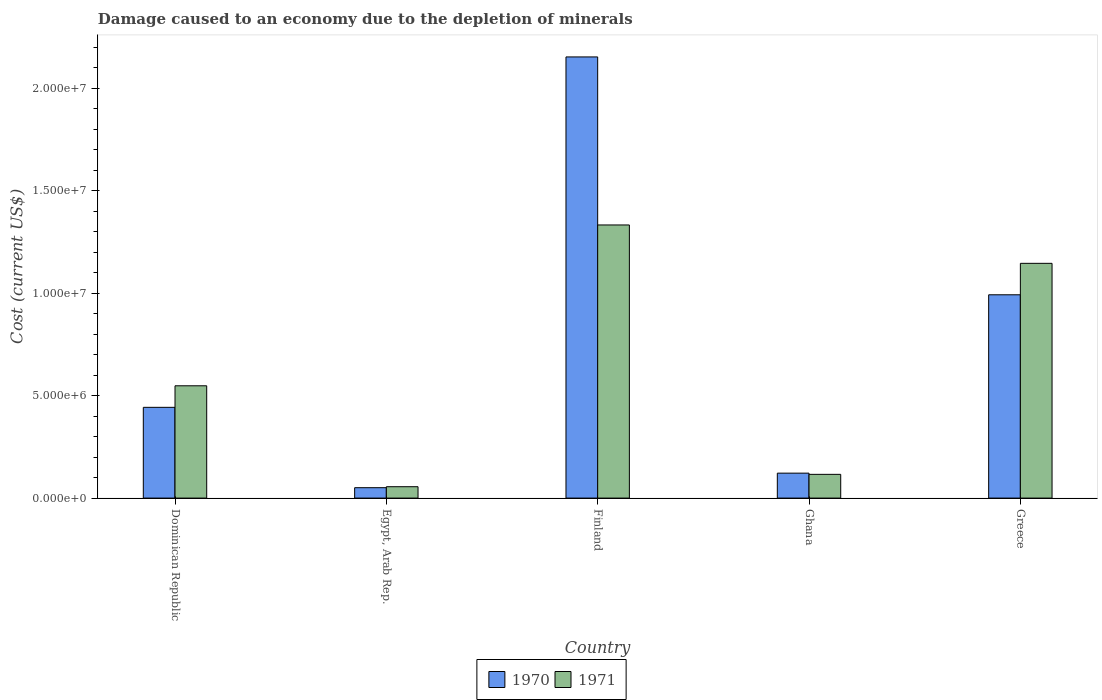How many bars are there on the 5th tick from the left?
Offer a terse response. 2. How many bars are there on the 4th tick from the right?
Provide a succinct answer. 2. What is the cost of damage caused due to the depletion of minerals in 1970 in Finland?
Make the answer very short. 2.15e+07. Across all countries, what is the maximum cost of damage caused due to the depletion of minerals in 1970?
Offer a very short reply. 2.15e+07. Across all countries, what is the minimum cost of damage caused due to the depletion of minerals in 1971?
Your response must be concise. 5.55e+05. In which country was the cost of damage caused due to the depletion of minerals in 1970 maximum?
Provide a short and direct response. Finland. In which country was the cost of damage caused due to the depletion of minerals in 1971 minimum?
Make the answer very short. Egypt, Arab Rep. What is the total cost of damage caused due to the depletion of minerals in 1971 in the graph?
Make the answer very short. 3.20e+07. What is the difference between the cost of damage caused due to the depletion of minerals in 1971 in Dominican Republic and that in Ghana?
Keep it short and to the point. 4.32e+06. What is the difference between the cost of damage caused due to the depletion of minerals in 1971 in Dominican Republic and the cost of damage caused due to the depletion of minerals in 1970 in Greece?
Your answer should be very brief. -4.44e+06. What is the average cost of damage caused due to the depletion of minerals in 1970 per country?
Make the answer very short. 7.52e+06. What is the difference between the cost of damage caused due to the depletion of minerals of/in 1971 and cost of damage caused due to the depletion of minerals of/in 1970 in Ghana?
Offer a terse response. -5.86e+04. What is the ratio of the cost of damage caused due to the depletion of minerals in 1971 in Egypt, Arab Rep. to that in Ghana?
Offer a very short reply. 0.48. Is the difference between the cost of damage caused due to the depletion of minerals in 1971 in Finland and Ghana greater than the difference between the cost of damage caused due to the depletion of minerals in 1970 in Finland and Ghana?
Offer a very short reply. No. What is the difference between the highest and the second highest cost of damage caused due to the depletion of minerals in 1970?
Keep it short and to the point. -1.16e+07. What is the difference between the highest and the lowest cost of damage caused due to the depletion of minerals in 1970?
Keep it short and to the point. 2.10e+07. Is the sum of the cost of damage caused due to the depletion of minerals in 1970 in Dominican Republic and Finland greater than the maximum cost of damage caused due to the depletion of minerals in 1971 across all countries?
Provide a short and direct response. Yes. What does the 2nd bar from the right in Finland represents?
Ensure brevity in your answer.  1970. Are all the bars in the graph horizontal?
Give a very brief answer. No. How many legend labels are there?
Your answer should be compact. 2. What is the title of the graph?
Your answer should be very brief. Damage caused to an economy due to the depletion of minerals. What is the label or title of the X-axis?
Offer a terse response. Country. What is the label or title of the Y-axis?
Provide a succinct answer. Cost (current US$). What is the Cost (current US$) of 1970 in Dominican Republic?
Make the answer very short. 4.43e+06. What is the Cost (current US$) of 1971 in Dominican Republic?
Give a very brief answer. 5.48e+06. What is the Cost (current US$) of 1970 in Egypt, Arab Rep.?
Your answer should be compact. 5.07e+05. What is the Cost (current US$) of 1971 in Egypt, Arab Rep.?
Keep it short and to the point. 5.55e+05. What is the Cost (current US$) of 1970 in Finland?
Your response must be concise. 2.15e+07. What is the Cost (current US$) in 1971 in Finland?
Offer a very short reply. 1.33e+07. What is the Cost (current US$) of 1970 in Ghana?
Your answer should be very brief. 1.22e+06. What is the Cost (current US$) of 1971 in Ghana?
Ensure brevity in your answer.  1.16e+06. What is the Cost (current US$) of 1970 in Greece?
Ensure brevity in your answer.  9.92e+06. What is the Cost (current US$) of 1971 in Greece?
Your answer should be very brief. 1.15e+07. Across all countries, what is the maximum Cost (current US$) of 1970?
Give a very brief answer. 2.15e+07. Across all countries, what is the maximum Cost (current US$) in 1971?
Your answer should be very brief. 1.33e+07. Across all countries, what is the minimum Cost (current US$) of 1970?
Make the answer very short. 5.07e+05. Across all countries, what is the minimum Cost (current US$) in 1971?
Offer a very short reply. 5.55e+05. What is the total Cost (current US$) in 1970 in the graph?
Provide a short and direct response. 3.76e+07. What is the total Cost (current US$) in 1971 in the graph?
Ensure brevity in your answer.  3.20e+07. What is the difference between the Cost (current US$) of 1970 in Dominican Republic and that in Egypt, Arab Rep.?
Your answer should be compact. 3.92e+06. What is the difference between the Cost (current US$) of 1971 in Dominican Republic and that in Egypt, Arab Rep.?
Provide a short and direct response. 4.92e+06. What is the difference between the Cost (current US$) in 1970 in Dominican Republic and that in Finland?
Your response must be concise. -1.71e+07. What is the difference between the Cost (current US$) of 1971 in Dominican Republic and that in Finland?
Provide a short and direct response. -7.85e+06. What is the difference between the Cost (current US$) of 1970 in Dominican Republic and that in Ghana?
Ensure brevity in your answer.  3.21e+06. What is the difference between the Cost (current US$) in 1971 in Dominican Republic and that in Ghana?
Offer a very short reply. 4.32e+06. What is the difference between the Cost (current US$) of 1970 in Dominican Republic and that in Greece?
Provide a succinct answer. -5.49e+06. What is the difference between the Cost (current US$) in 1971 in Dominican Republic and that in Greece?
Provide a succinct answer. -5.97e+06. What is the difference between the Cost (current US$) of 1970 in Egypt, Arab Rep. and that in Finland?
Your answer should be compact. -2.10e+07. What is the difference between the Cost (current US$) in 1971 in Egypt, Arab Rep. and that in Finland?
Your answer should be very brief. -1.28e+07. What is the difference between the Cost (current US$) in 1970 in Egypt, Arab Rep. and that in Ghana?
Your answer should be very brief. -7.10e+05. What is the difference between the Cost (current US$) of 1971 in Egypt, Arab Rep. and that in Ghana?
Provide a short and direct response. -6.03e+05. What is the difference between the Cost (current US$) in 1970 in Egypt, Arab Rep. and that in Greece?
Offer a very short reply. -9.41e+06. What is the difference between the Cost (current US$) of 1971 in Egypt, Arab Rep. and that in Greece?
Offer a terse response. -1.09e+07. What is the difference between the Cost (current US$) of 1970 in Finland and that in Ghana?
Provide a succinct answer. 2.03e+07. What is the difference between the Cost (current US$) in 1971 in Finland and that in Ghana?
Make the answer very short. 1.22e+07. What is the difference between the Cost (current US$) of 1970 in Finland and that in Greece?
Make the answer very short. 1.16e+07. What is the difference between the Cost (current US$) in 1971 in Finland and that in Greece?
Provide a succinct answer. 1.87e+06. What is the difference between the Cost (current US$) of 1970 in Ghana and that in Greece?
Offer a terse response. -8.70e+06. What is the difference between the Cost (current US$) in 1971 in Ghana and that in Greece?
Make the answer very short. -1.03e+07. What is the difference between the Cost (current US$) in 1970 in Dominican Republic and the Cost (current US$) in 1971 in Egypt, Arab Rep.?
Ensure brevity in your answer.  3.87e+06. What is the difference between the Cost (current US$) of 1970 in Dominican Republic and the Cost (current US$) of 1971 in Finland?
Offer a very short reply. -8.90e+06. What is the difference between the Cost (current US$) in 1970 in Dominican Republic and the Cost (current US$) in 1971 in Ghana?
Offer a terse response. 3.27e+06. What is the difference between the Cost (current US$) in 1970 in Dominican Republic and the Cost (current US$) in 1971 in Greece?
Ensure brevity in your answer.  -7.02e+06. What is the difference between the Cost (current US$) of 1970 in Egypt, Arab Rep. and the Cost (current US$) of 1971 in Finland?
Offer a terse response. -1.28e+07. What is the difference between the Cost (current US$) of 1970 in Egypt, Arab Rep. and the Cost (current US$) of 1971 in Ghana?
Offer a terse response. -6.51e+05. What is the difference between the Cost (current US$) in 1970 in Egypt, Arab Rep. and the Cost (current US$) in 1971 in Greece?
Make the answer very short. -1.09e+07. What is the difference between the Cost (current US$) in 1970 in Finland and the Cost (current US$) in 1971 in Ghana?
Provide a succinct answer. 2.04e+07. What is the difference between the Cost (current US$) in 1970 in Finland and the Cost (current US$) in 1971 in Greece?
Your answer should be compact. 1.01e+07. What is the difference between the Cost (current US$) of 1970 in Ghana and the Cost (current US$) of 1971 in Greece?
Offer a terse response. -1.02e+07. What is the average Cost (current US$) of 1970 per country?
Provide a short and direct response. 7.52e+06. What is the average Cost (current US$) of 1971 per country?
Provide a succinct answer. 6.39e+06. What is the difference between the Cost (current US$) of 1970 and Cost (current US$) of 1971 in Dominican Republic?
Make the answer very short. -1.05e+06. What is the difference between the Cost (current US$) of 1970 and Cost (current US$) of 1971 in Egypt, Arab Rep.?
Provide a succinct answer. -4.79e+04. What is the difference between the Cost (current US$) of 1970 and Cost (current US$) of 1971 in Finland?
Your response must be concise. 8.20e+06. What is the difference between the Cost (current US$) of 1970 and Cost (current US$) of 1971 in Ghana?
Keep it short and to the point. 5.86e+04. What is the difference between the Cost (current US$) of 1970 and Cost (current US$) of 1971 in Greece?
Provide a short and direct response. -1.53e+06. What is the ratio of the Cost (current US$) in 1970 in Dominican Republic to that in Egypt, Arab Rep.?
Make the answer very short. 8.73. What is the ratio of the Cost (current US$) in 1971 in Dominican Republic to that in Egypt, Arab Rep.?
Provide a short and direct response. 9.87. What is the ratio of the Cost (current US$) in 1970 in Dominican Republic to that in Finland?
Your response must be concise. 0.21. What is the ratio of the Cost (current US$) in 1971 in Dominican Republic to that in Finland?
Provide a short and direct response. 0.41. What is the ratio of the Cost (current US$) of 1970 in Dominican Republic to that in Ghana?
Your answer should be compact. 3.64. What is the ratio of the Cost (current US$) of 1971 in Dominican Republic to that in Ghana?
Your answer should be very brief. 4.73. What is the ratio of the Cost (current US$) in 1970 in Dominican Republic to that in Greece?
Give a very brief answer. 0.45. What is the ratio of the Cost (current US$) of 1971 in Dominican Republic to that in Greece?
Provide a succinct answer. 0.48. What is the ratio of the Cost (current US$) of 1970 in Egypt, Arab Rep. to that in Finland?
Your answer should be very brief. 0.02. What is the ratio of the Cost (current US$) in 1971 in Egypt, Arab Rep. to that in Finland?
Ensure brevity in your answer.  0.04. What is the ratio of the Cost (current US$) of 1970 in Egypt, Arab Rep. to that in Ghana?
Give a very brief answer. 0.42. What is the ratio of the Cost (current US$) of 1971 in Egypt, Arab Rep. to that in Ghana?
Offer a terse response. 0.48. What is the ratio of the Cost (current US$) in 1970 in Egypt, Arab Rep. to that in Greece?
Offer a very short reply. 0.05. What is the ratio of the Cost (current US$) in 1971 in Egypt, Arab Rep. to that in Greece?
Provide a short and direct response. 0.05. What is the ratio of the Cost (current US$) in 1970 in Finland to that in Ghana?
Your response must be concise. 17.68. What is the ratio of the Cost (current US$) of 1971 in Finland to that in Ghana?
Your answer should be very brief. 11.5. What is the ratio of the Cost (current US$) of 1970 in Finland to that in Greece?
Ensure brevity in your answer.  2.17. What is the ratio of the Cost (current US$) of 1971 in Finland to that in Greece?
Make the answer very short. 1.16. What is the ratio of the Cost (current US$) of 1970 in Ghana to that in Greece?
Provide a short and direct response. 0.12. What is the ratio of the Cost (current US$) in 1971 in Ghana to that in Greece?
Ensure brevity in your answer.  0.1. What is the difference between the highest and the second highest Cost (current US$) in 1970?
Provide a succinct answer. 1.16e+07. What is the difference between the highest and the second highest Cost (current US$) of 1971?
Ensure brevity in your answer.  1.87e+06. What is the difference between the highest and the lowest Cost (current US$) in 1970?
Provide a succinct answer. 2.10e+07. What is the difference between the highest and the lowest Cost (current US$) in 1971?
Your response must be concise. 1.28e+07. 